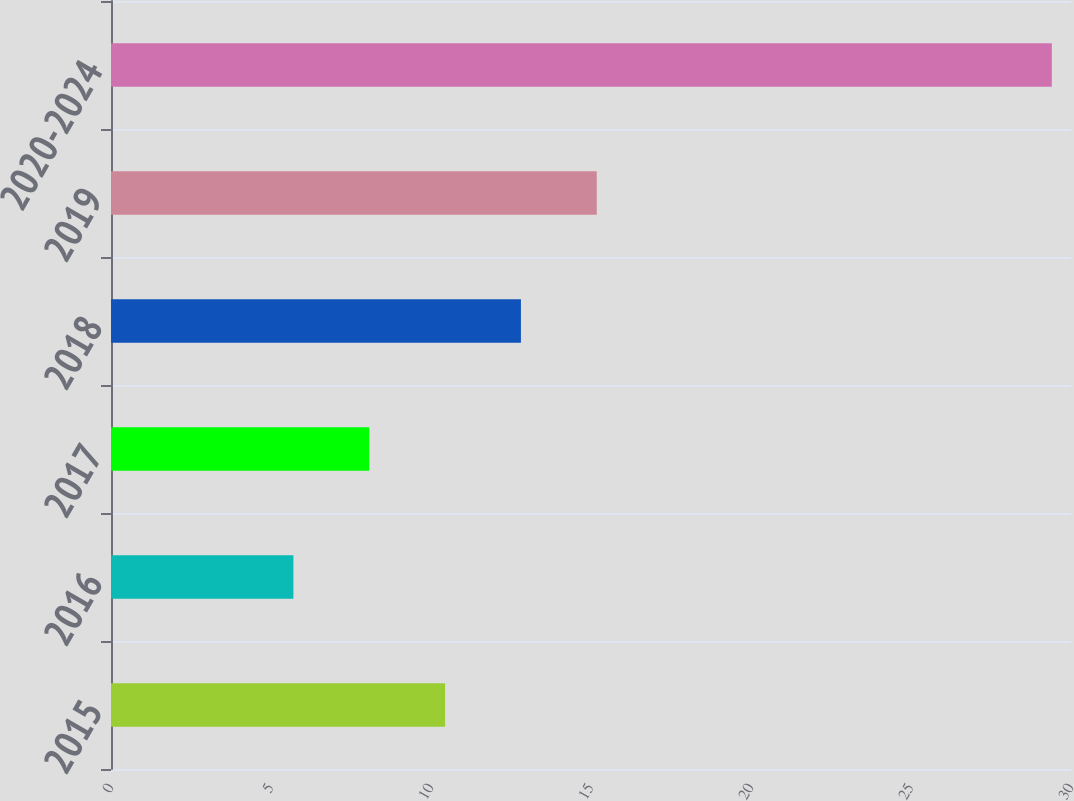Convert chart. <chart><loc_0><loc_0><loc_500><loc_500><bar_chart><fcel>2015<fcel>2016<fcel>2017<fcel>2018<fcel>2019<fcel>2020-2024<nl><fcel>10.44<fcel>5.7<fcel>8.07<fcel>12.81<fcel>15.18<fcel>29.4<nl></chart> 